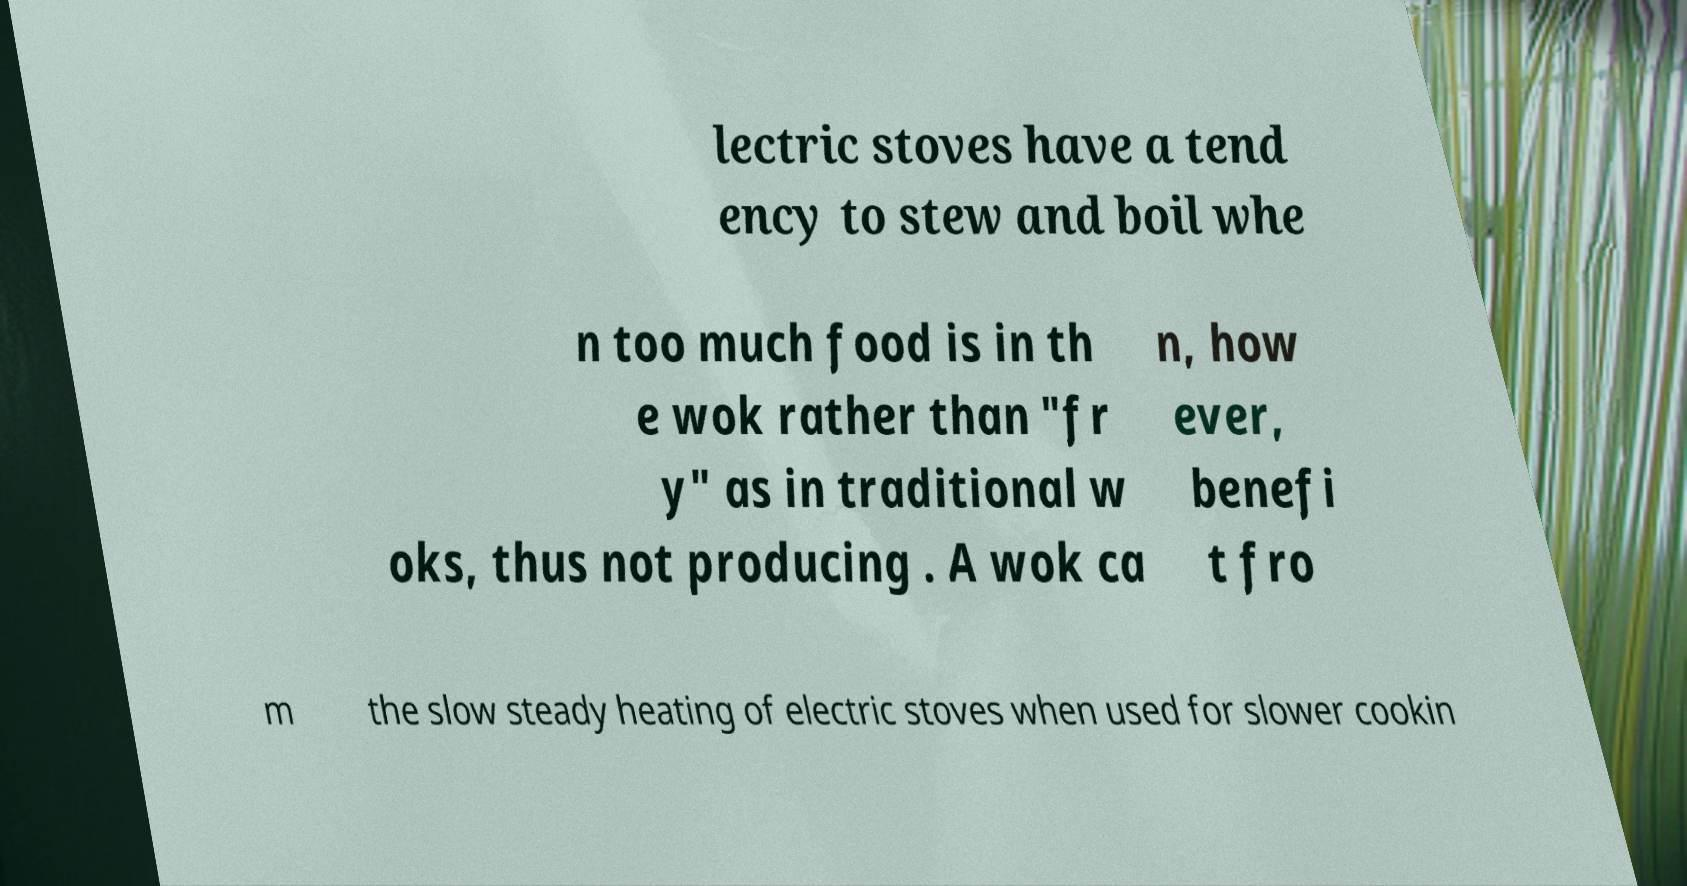Can you read and provide the text displayed in the image?This photo seems to have some interesting text. Can you extract and type it out for me? lectric stoves have a tend ency to stew and boil whe n too much food is in th e wok rather than "fr y" as in traditional w oks, thus not producing . A wok ca n, how ever, benefi t fro m the slow steady heating of electric stoves when used for slower cookin 